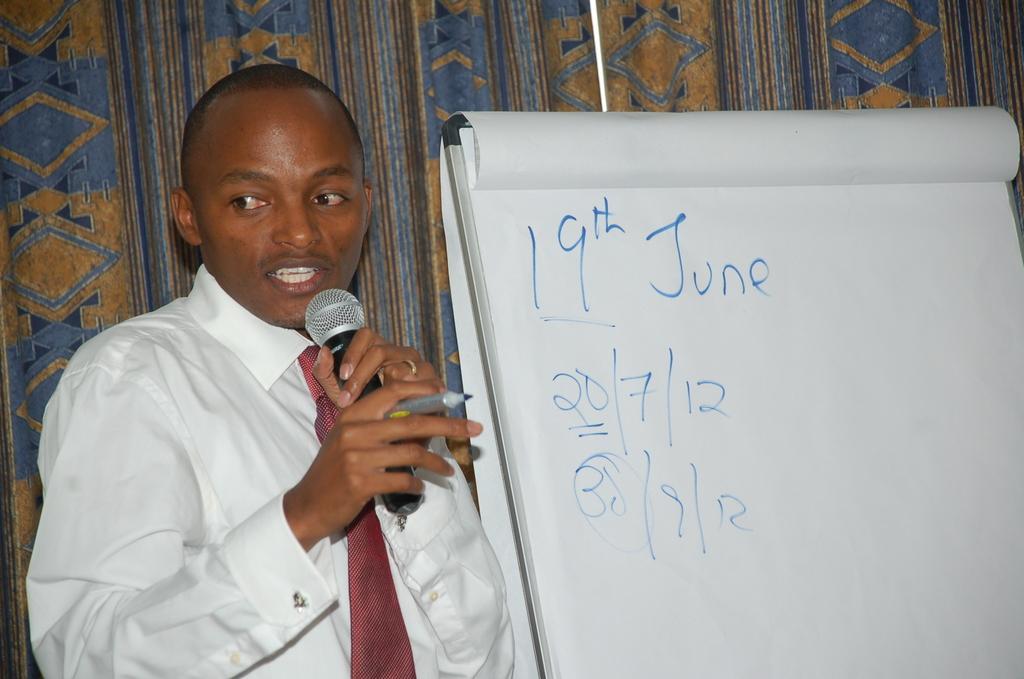Could you give a brief overview of what you see in this image? Here in this picture we can see a person speaking something in the microphone present in his hand and we can see he is also carrying a sketch and beside him we can see a board with charts on it and we can see some dates written on the chart over there and behind him we can see curtain present over there. 